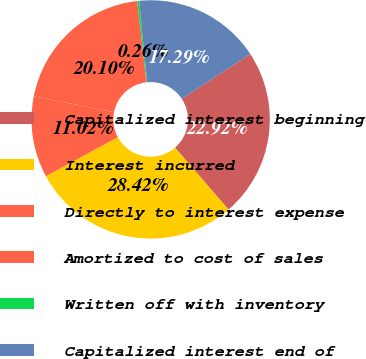Convert chart. <chart><loc_0><loc_0><loc_500><loc_500><pie_chart><fcel>Capitalized interest beginning<fcel>Interest incurred<fcel>Directly to interest expense<fcel>Amortized to cost of sales<fcel>Written off with inventory<fcel>Capitalized interest end of<nl><fcel>22.92%<fcel>28.42%<fcel>11.02%<fcel>20.1%<fcel>0.26%<fcel>17.29%<nl></chart> 